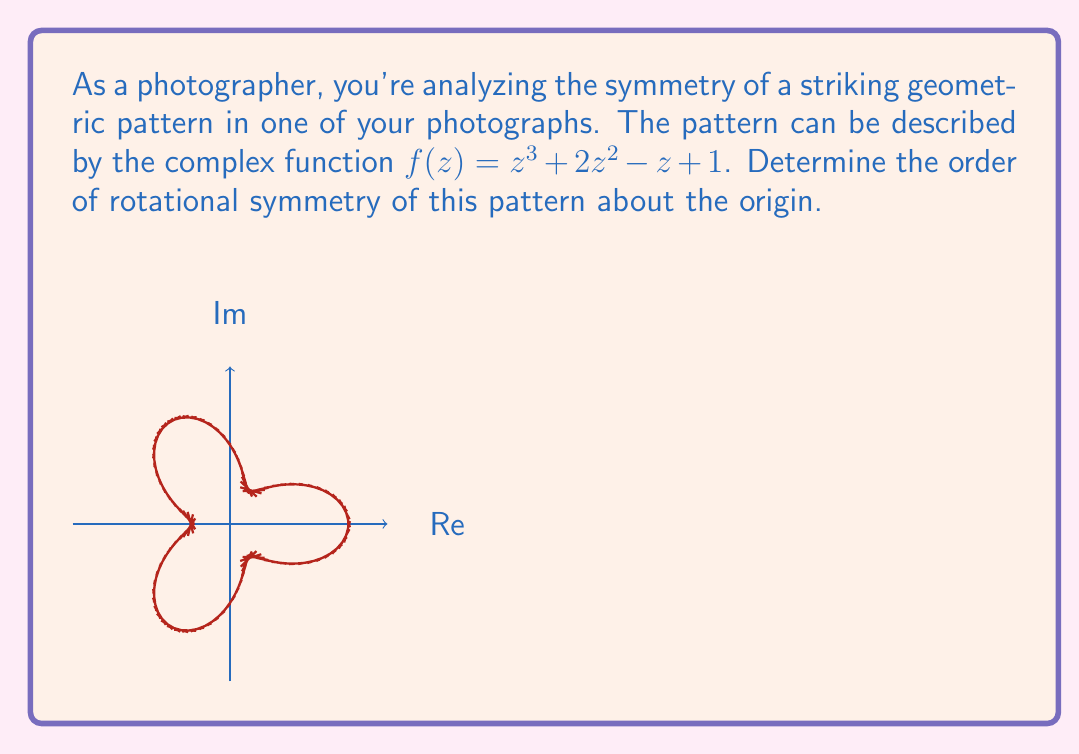Can you answer this question? To determine the order of rotational symmetry, we need to analyze how the function $f(z)$ behaves under rotations about the origin. Let's approach this step-by-step:

1) First, consider a rotation of $z$ by an angle $\theta$. This is equivalent to multiplying $z$ by $e^{i\theta}$:

   $z \rightarrow ze^{i\theta}$

2) Now, let's see how $f(z)$ changes under this rotation:

   $f(ze^{i\theta}) = (ze^{i\theta})^3 + 2(ze^{i\theta})^2 - (ze^{i\theta}) + 1$

3) Expand this:

   $f(ze^{i\theta}) = z^3e^{3i\theta} + 2z^2e^{2i\theta} - ze^{i\theta} + 1$

4) For the pattern to have rotational symmetry, this should equal $e^{in\theta}f(z)$ for some integer $n$:

   $z^3e^{3i\theta} + 2z^2e^{2i\theta} - ze^{i\theta} + 1 = e^{in\theta}(z^3 + 2z^2 - z + 1)$

5) Comparing terms, we see that this equality holds when:

   $e^{3i\theta} = e^{2i\theta} = e^{i\theta} = e^{in\theta}$

6) This is true when $\theta = \frac{2\pi}{3}$, and $n = 3$.

7) Therefore, the pattern has 3-fold rotational symmetry, meaning it repeats every $\frac{2\pi}{3}$ radians or 120°.
Answer: 3 